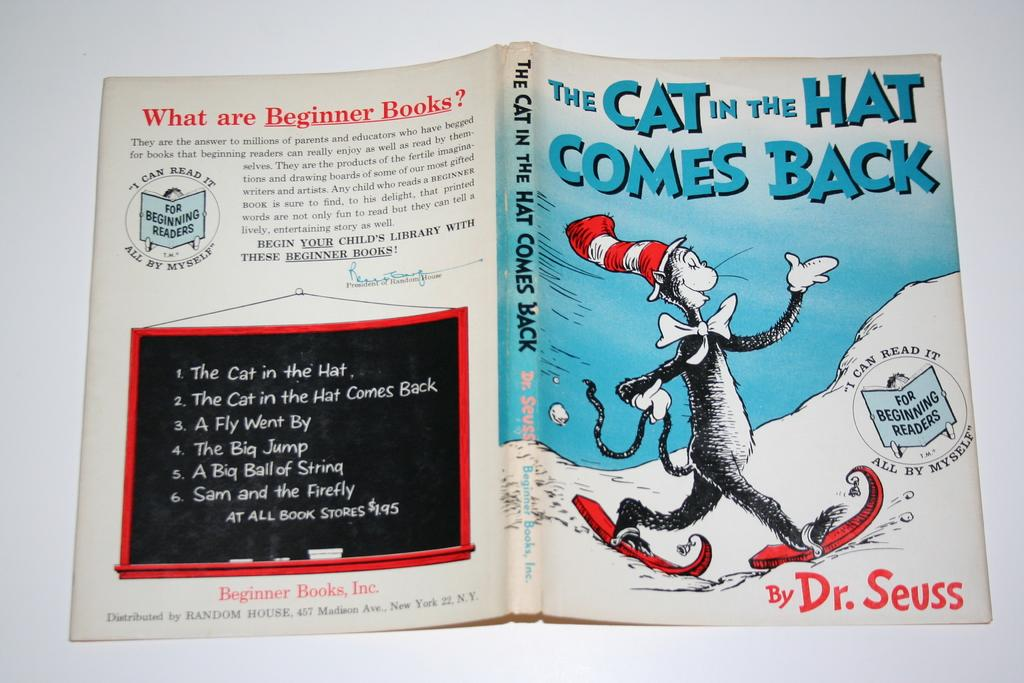<image>
Give a short and clear explanation of the subsequent image. The cover of a book with a black and white cat by Dr. Seuss. 